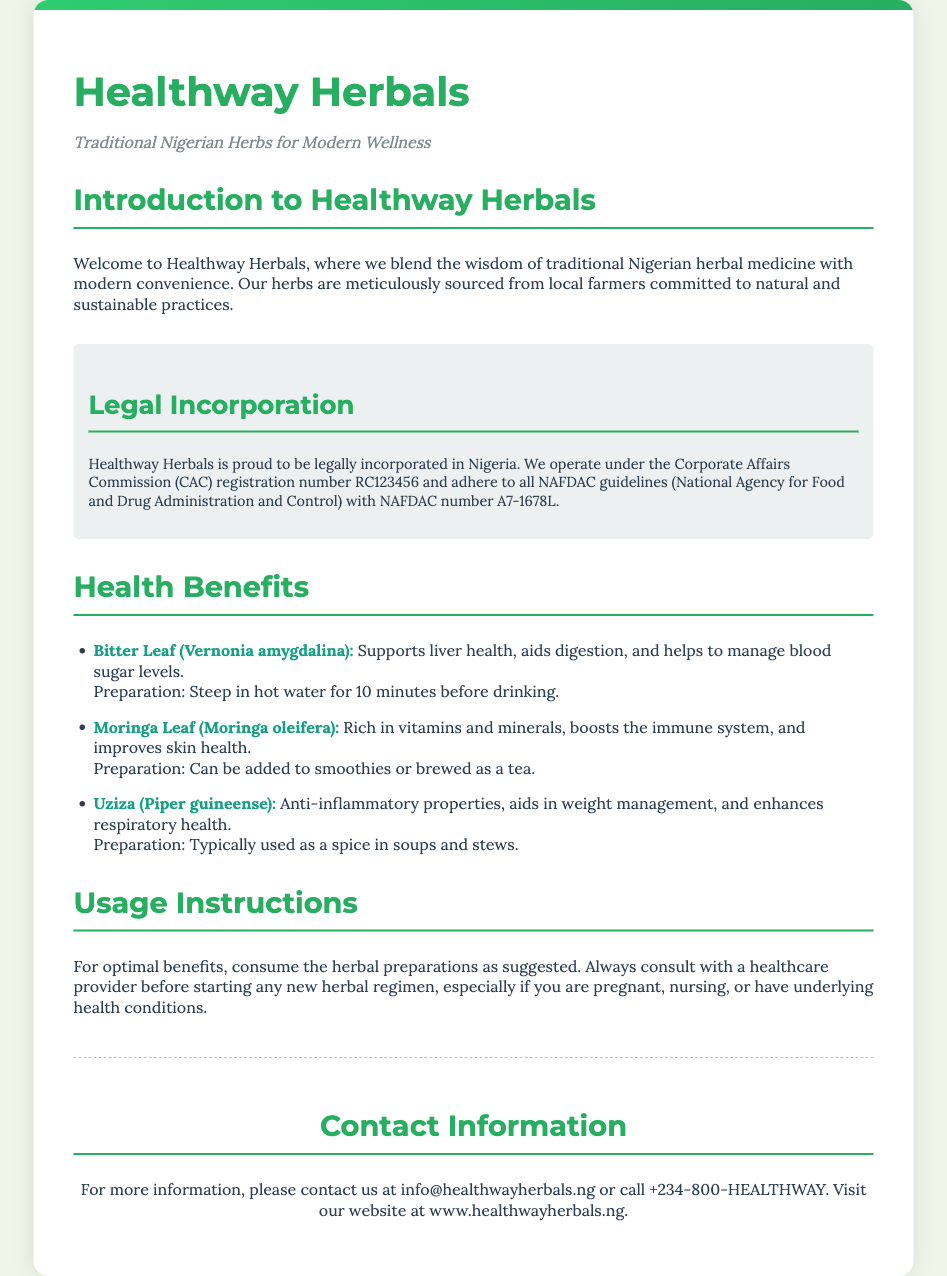What is the name of the company? The name of the company is mentioned in the title and throughout the document, which is Healthway Herbals.
Answer: Healthway Herbals What is the CA number for Healthway Herbals? The Corporate Affairs Commission registration number is provided in the legal incorporation section, which is RC123456.
Answer: RC123456 What is the NAFDAC number associated with the product? The NAFDAC number is provided in the legal incorporation section, which is A7-1678L.
Answer: A7-1678L What health benefit is associated with Bitter Leaf? The document lists several benefits of Bitter Leaf, focusing on liver health, digestion, and blood sugar management.
Answer: Supports liver health What preparation method is suggested for Moringa Leaf? The preparation method for Moringa Leaf is stated in the health benefits section as being added to smoothies or brewed as a tea.
Answer: Added to smoothies or brewed as tea Which herb is noted for anti-inflammatory properties? The document specifically mentions Uziza (Piper guineense) for its anti-inflammatory properties.
Answer: Uziza What should be consulted before starting any new herbal regimen? The document advises consulting a healthcare provider before starting a new herbal regimen.
Answer: Healthcare provider In which country is Healthway Herbals legally incorporated? The incorporation information specifies that Healthway Herbals is incorporated in Nigeria.
Answer: Nigeria What is the purpose of Healthway Herbals as stated in the introduction? The introduction mentions that Healthway Herbals blends traditional Nigerian herbal medicine with modern convenience.
Answer: Blend traditional medicine with modern convenience 